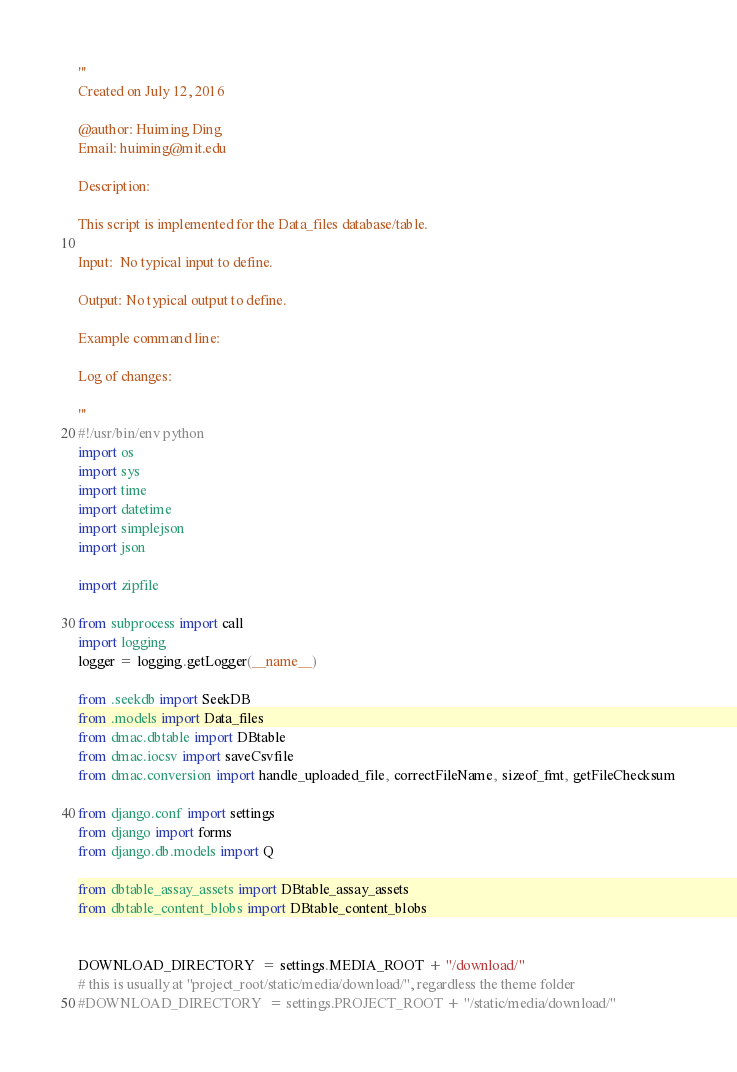Convert code to text. <code><loc_0><loc_0><loc_500><loc_500><_Python_>'''
Created on July 12, 2016

@author: Huiming Ding
Email: huiming@mit.edu

Description:

This script is implemented for the Data_files database/table.

Input:  No typical input to define.
       
Output: No typical output to define.
        
Example command line:
     
Log of changes:
     
'''
#!/usr/bin/env python
import os
import sys
import time
import datetime
import simplejson
import json

import zipfile

from subprocess import call
import logging
logger = logging.getLogger(__name__)

from .seekdb import SeekDB
from .models import Data_files
from dmac.dbtable import DBtable
from dmac.iocsv import saveCsvfile
from dmac.conversion import handle_uploaded_file, correctFileName, sizeof_fmt, getFileChecksum

from django.conf import settings
from django import forms
from django.db.models import Q

from dbtable_assay_assets import DBtable_assay_assets
from dbtable_content_blobs import DBtable_content_blobs


DOWNLOAD_DIRECTORY  = settings.MEDIA_ROOT + "/download/"
# this is usually at "project_root/static/media/download/", regardless the theme folder
#DOWNLOAD_DIRECTORY  = settings.PROJECT_ROOT + "/static/media/download/"
</code> 